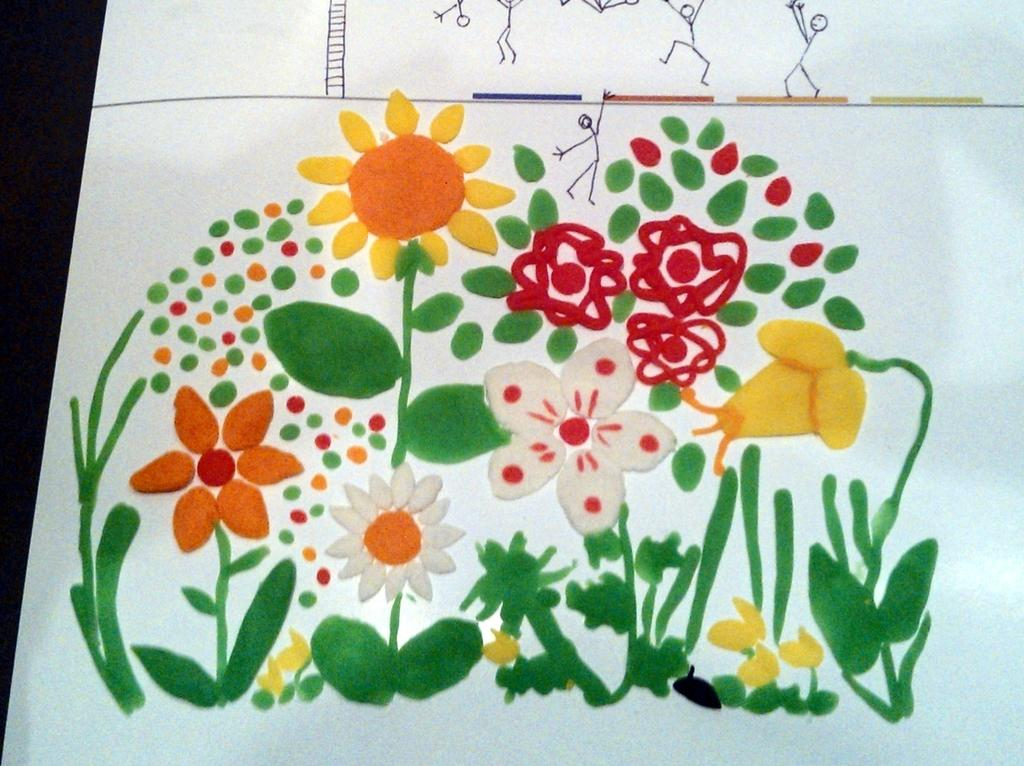What is the primary color of the sheet in the image? The sheet in the image is white. What type of artwork is featured on the sheet? The sheet contains paintings of flowers and leaves. Are there any cracks in the sheet that might indicate a pest infestation in the image? There is no mention of cracks or pest infestation in the image; it only features a white sheet with paintings of flowers and leaves. 